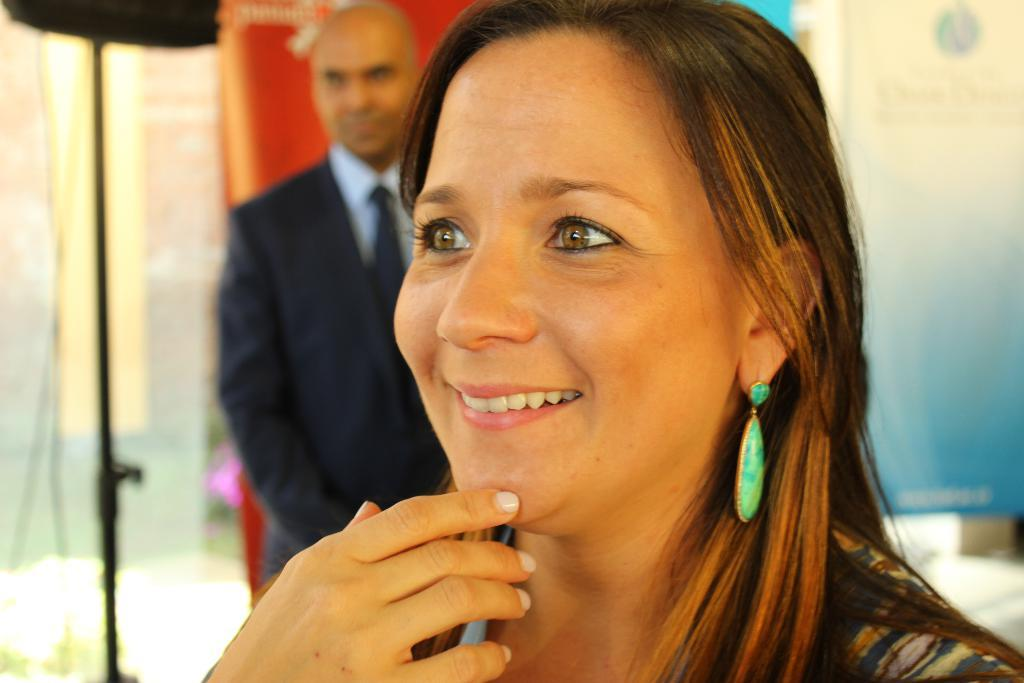Who is present in the image? There is a woman in the image. What is the woman doing in the image? The woman is smiling in the image. Is there anyone else in the image besides the woman? Yes, there is a man standing behind the woman in the image. What type of island can be seen in the background of the image? There is no island visible in the image; it only features a woman and a man. 